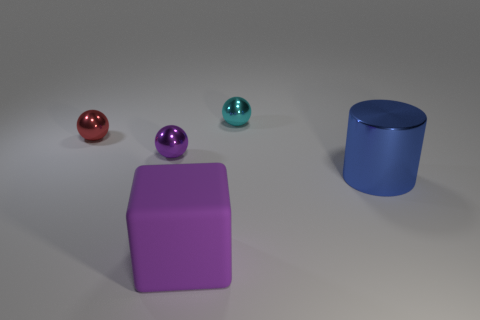Add 3 blue things. How many objects exist? 8 Subtract all tiny red spheres. How many spheres are left? 2 Subtract all blocks. How many objects are left? 4 Add 4 red spheres. How many red spheres are left? 5 Add 5 big brown metal spheres. How many big brown metal spheres exist? 5 Subtract 0 purple cylinders. How many objects are left? 5 Subtract all large green cylinders. Subtract all small cyan metal objects. How many objects are left? 4 